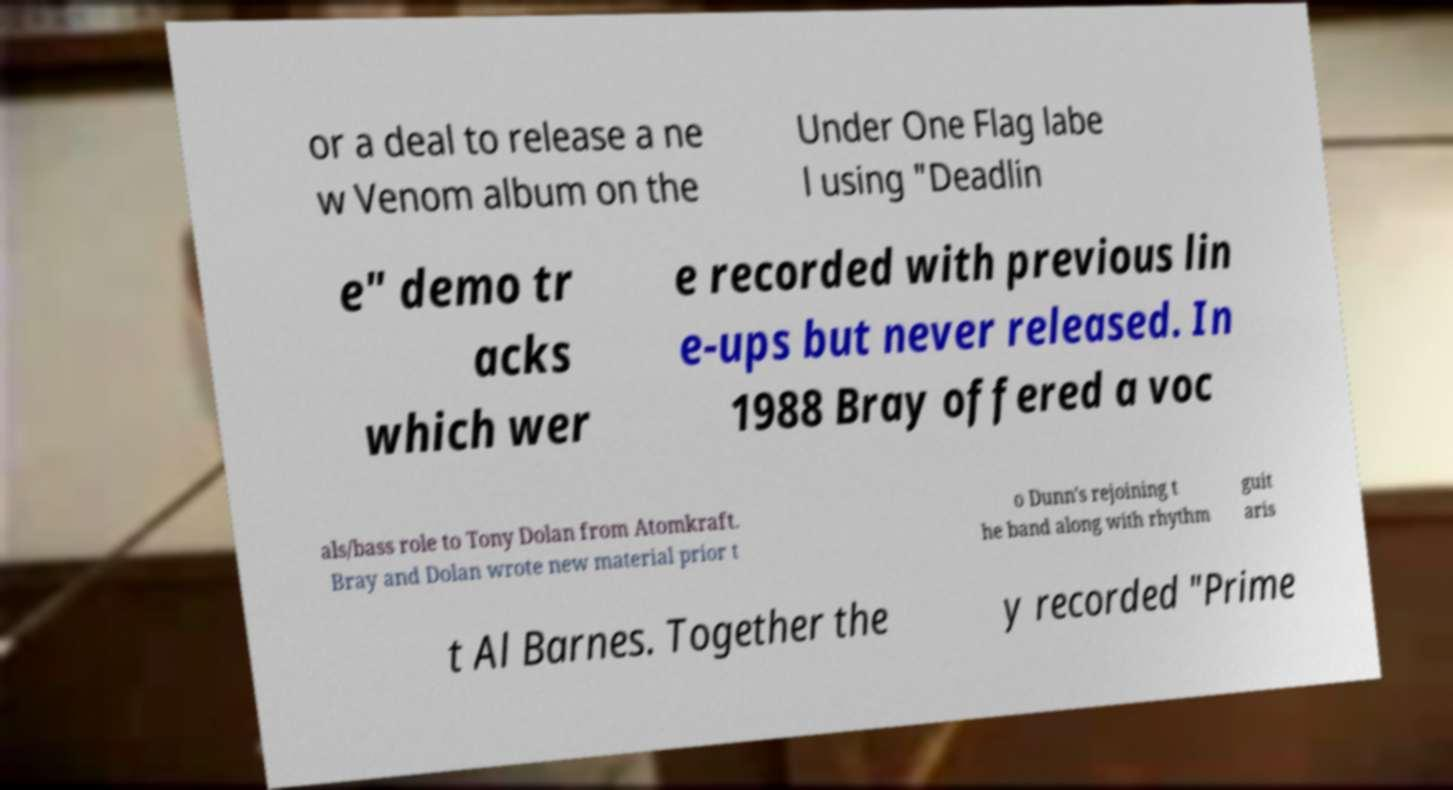For documentation purposes, I need the text within this image transcribed. Could you provide that? or a deal to release a ne w Venom album on the Under One Flag labe l using "Deadlin e" demo tr acks which wer e recorded with previous lin e-ups but never released. In 1988 Bray offered a voc als/bass role to Tony Dolan from Atomkraft. Bray and Dolan wrote new material prior t o Dunn's rejoining t he band along with rhythm guit aris t Al Barnes. Together the y recorded "Prime 